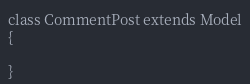<code> <loc_0><loc_0><loc_500><loc_500><_PHP_>

class CommentPost extends Model
{
    
}
</code> 